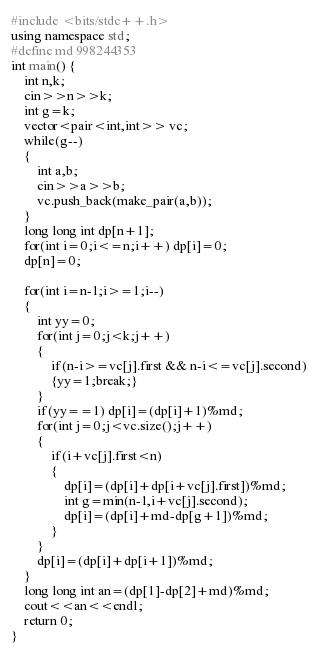Convert code to text. <code><loc_0><loc_0><loc_500><loc_500><_C++_>#include <bits/stdc++.h>
using namespace std;
#define md 998244353
int main() {
    int n,k;
    cin>>n>>k;
    int g=k;
    vector<pair<int,int>> vc;
    while(g--)
    {
    	int a,b;
    	cin>>a>>b;
    	vc.push_back(make_pair(a,b));
    }
    long long int dp[n+1];
    for(int i=0;i<=n;i++) dp[i]=0;
    dp[n]=0;

    for(int i=n-1;i>=1;i--)
    {
    	int yy=0;
    	for(int j=0;j<k;j++)
    	{
    		if(n-i>=vc[j].first && n-i<=vc[j].second)
    		{yy=1;break;}
    	}
    	if(yy==1) dp[i]=(dp[i]+1)%md;
    	for(int j=0;j<vc.size();j++)
    	{
    		if(i+vc[j].first<n) 
    		{
    			dp[i]=(dp[i]+dp[i+vc[j].first])%md;
    			int g=min(n-1,i+vc[j].second);
    			dp[i]=(dp[i]+md-dp[g+1])%md;
    		}
    	}
    	dp[i]=(dp[i]+dp[i+1])%md;
    }
    long long int an=(dp[1]-dp[2]+md)%md;
    cout<<an<<endl;
	return 0;
}</code> 